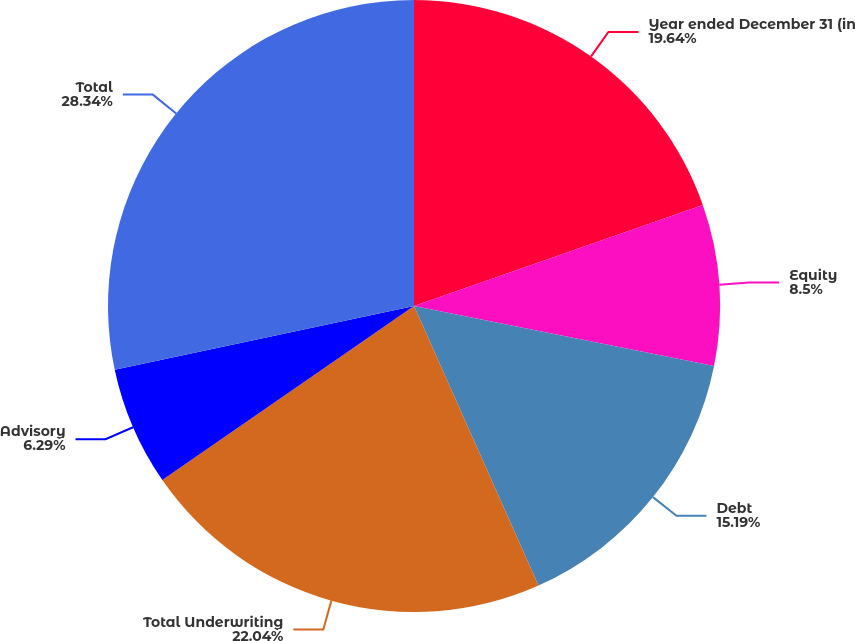Convert chart. <chart><loc_0><loc_0><loc_500><loc_500><pie_chart><fcel>Year ended December 31 (in<fcel>Equity<fcel>Debt<fcel>Total Underwriting<fcel>Advisory<fcel>Total<nl><fcel>19.64%<fcel>8.5%<fcel>15.19%<fcel>22.04%<fcel>6.29%<fcel>28.34%<nl></chart> 